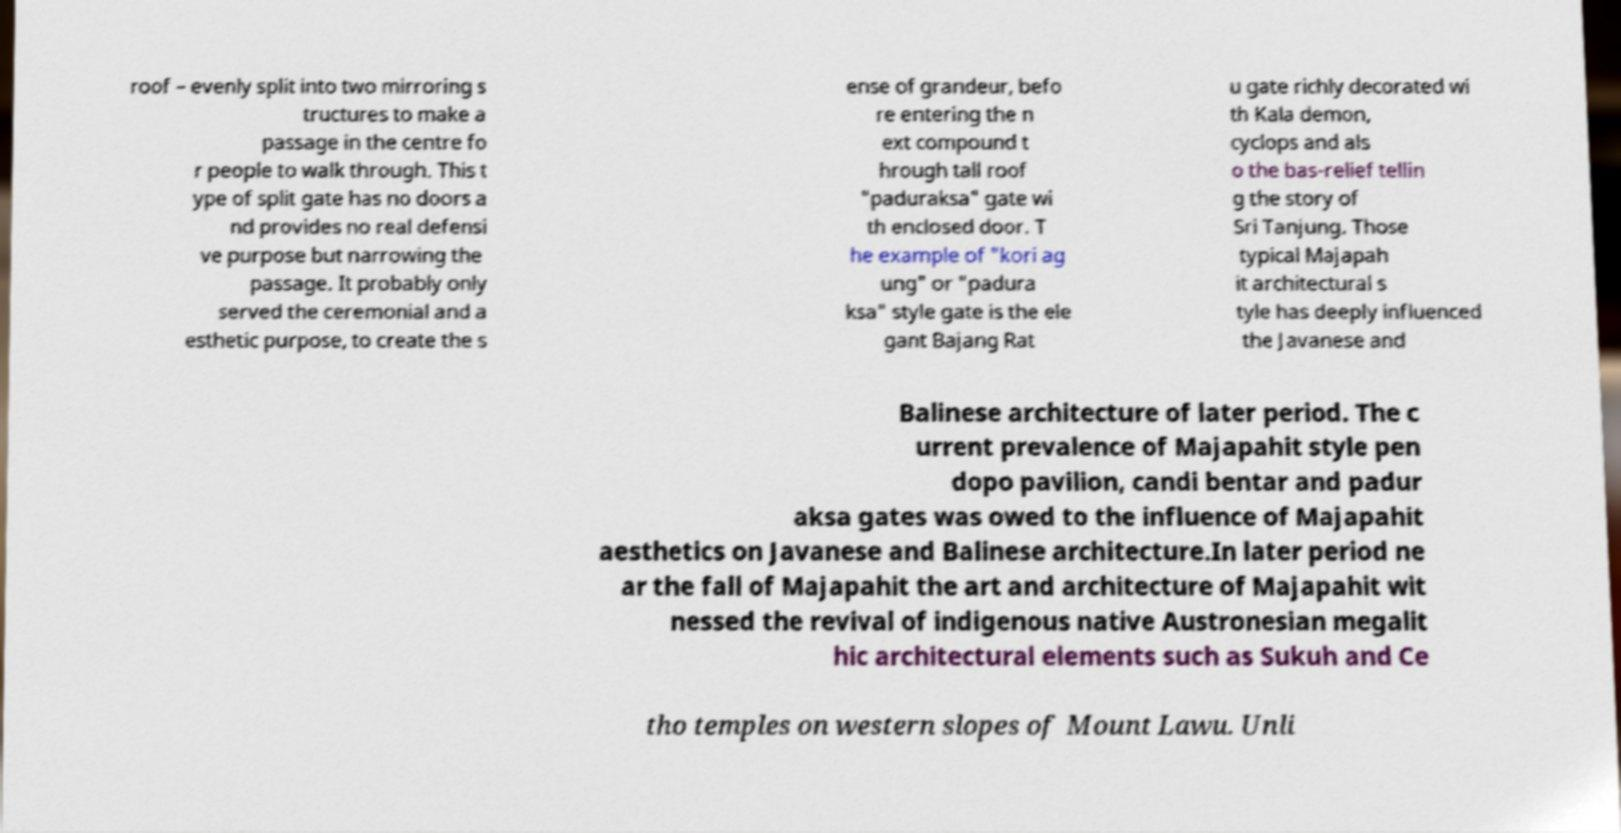For documentation purposes, I need the text within this image transcribed. Could you provide that? roof – evenly split into two mirroring s tructures to make a passage in the centre fo r people to walk through. This t ype of split gate has no doors a nd provides no real defensi ve purpose but narrowing the passage. It probably only served the ceremonial and a esthetic purpose, to create the s ense of grandeur, befo re entering the n ext compound t hrough tall roof "paduraksa" gate wi th enclosed door. T he example of "kori ag ung" or "padura ksa" style gate is the ele gant Bajang Rat u gate richly decorated wi th Kala demon, cyclops and als o the bas-relief tellin g the story of Sri Tanjung. Those typical Majapah it architectural s tyle has deeply influenced the Javanese and Balinese architecture of later period. The c urrent prevalence of Majapahit style pen dopo pavilion, candi bentar and padur aksa gates was owed to the influence of Majapahit aesthetics on Javanese and Balinese architecture.In later period ne ar the fall of Majapahit the art and architecture of Majapahit wit nessed the revival of indigenous native Austronesian megalit hic architectural elements such as Sukuh and Ce tho temples on western slopes of Mount Lawu. Unli 